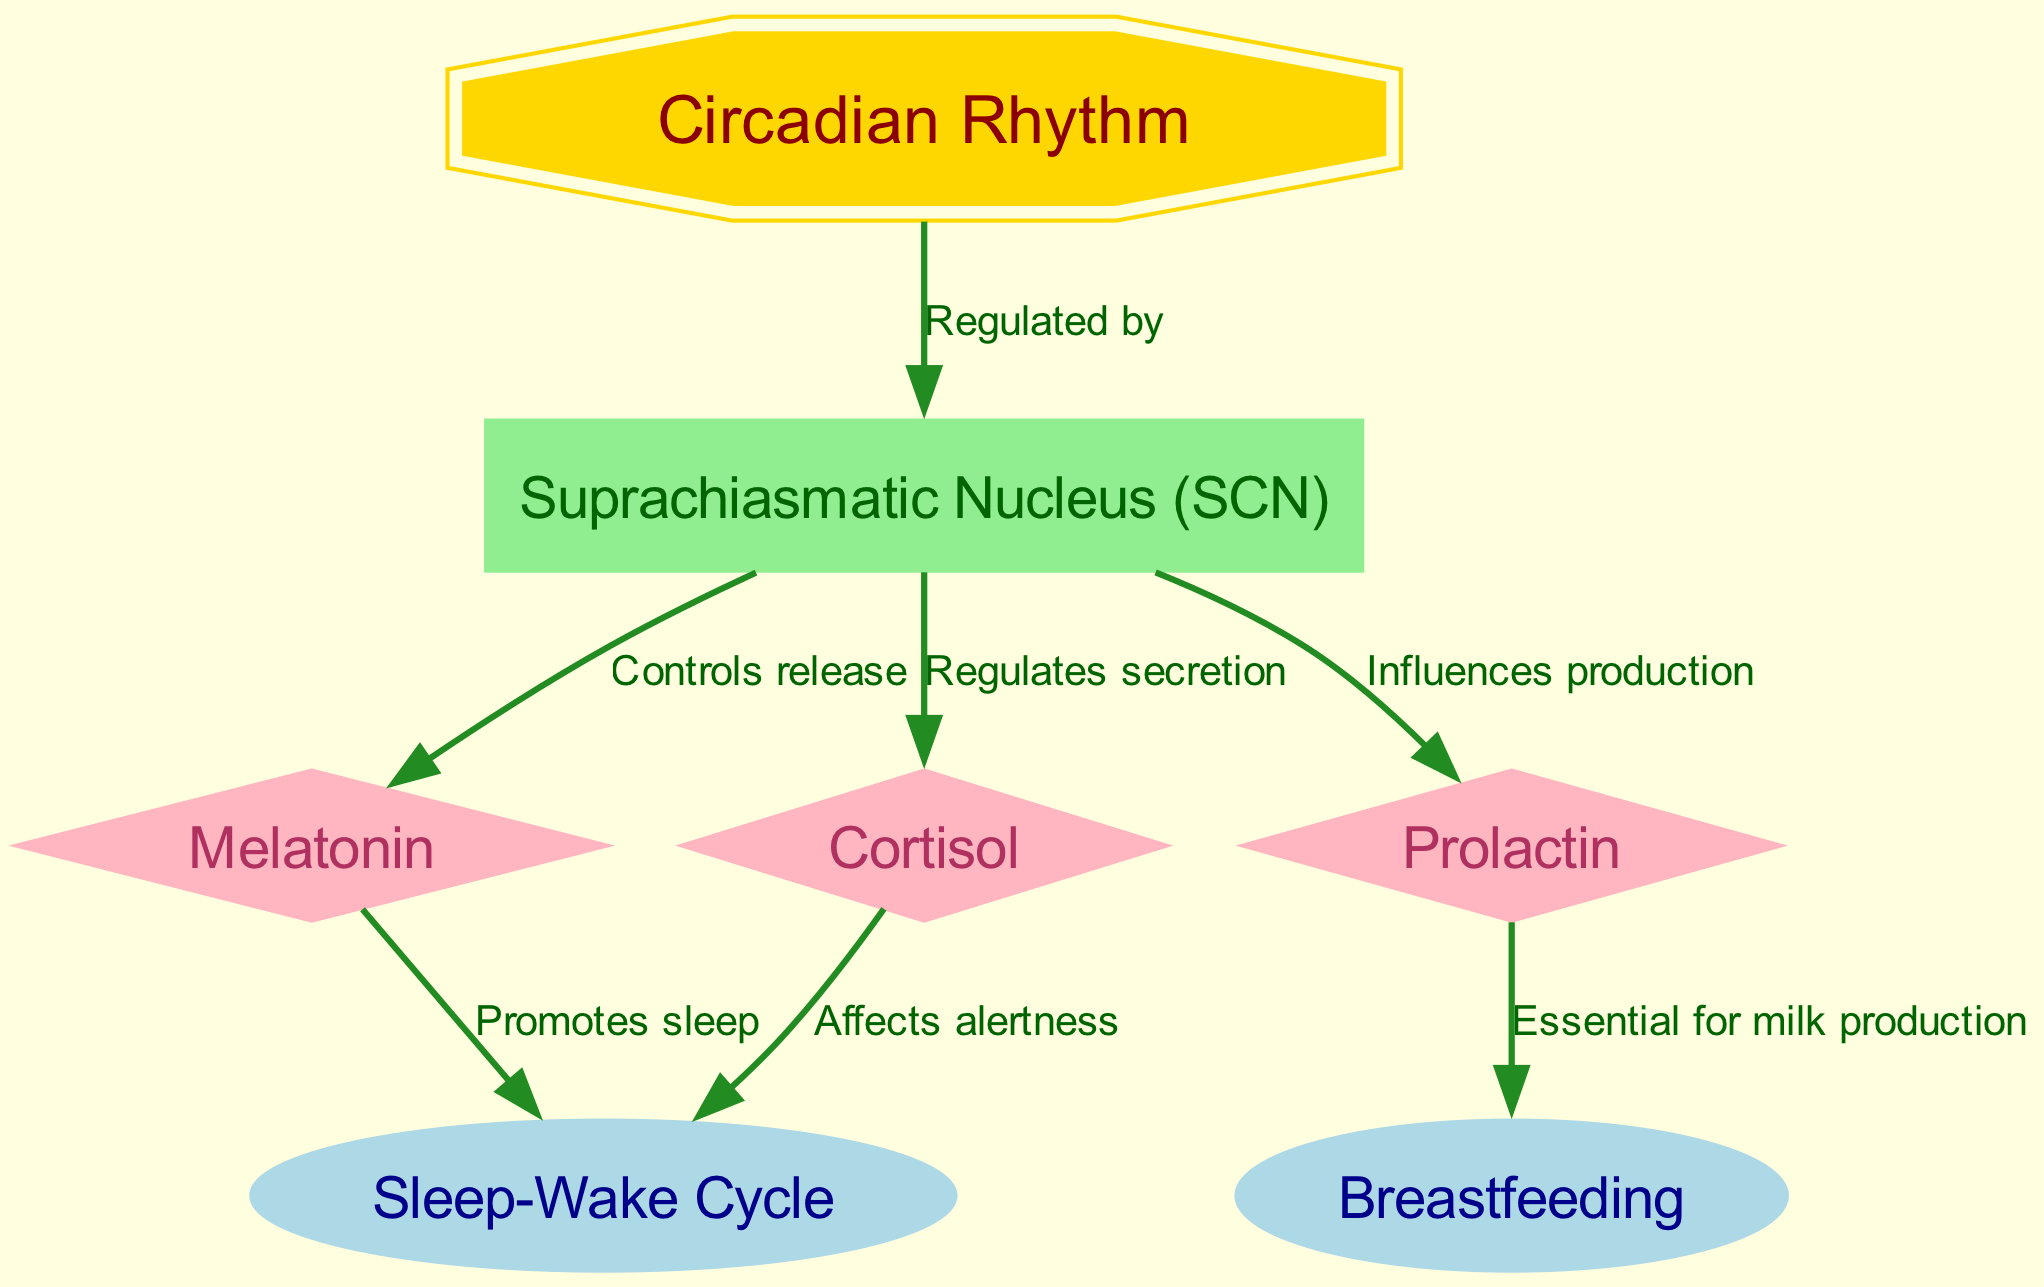What regulates the circadian rhythm? The diagram shows an edge labeled "Regulated by" from "Circadian Rhythm" to "Suprachiasmatic Nucleus (SCN)," indicating that the SCN regulates the circadian rhythm.
Answer: Suprachiasmatic Nucleus (SCN) Which hormone influences prolactin production? The edge from "Suprachiasmatic Nucleus" to "Prolactin" is labeled "Influences production," which means the SCN influences the production of prolactin.
Answer: Suprachiasmatic Nucleus How many hormones are shown in the diagram? By counting the nodes that represent hormones, namely "Melatonin," "Prolactin," and "Cortisol," there are a total of three hormones represented in the diagram.
Answer: 3 What effect does melatonin have on the sleep-wake cycle? The diagram has an edge from "Melatonin" to "Sleep-Wake Cycle" labeled "Promotes sleep," indicating that melatonin promotes sleep within the sleep-wake cycle.
Answer: Promotes sleep Which hormone is essential for milk production? The edge from "Prolactin" to "Breastfeeding" is labeled "Essential for milk production," indicating that prolactin is the hormone essential for that process.
Answer: Prolactin What does cortisol affect according to the diagram? The edge from "Cortisol" to "Sleep-Wake Cycle" is labeled "Affects alertness," which shows that cortisol affects alertness within the context of the sleep-wake cycle.
Answer: Alertness How does the suprachiasmatic nucleus interact with cortisol? The diagram indicates that the suprachiasmatic nucleus regulates the secretion of cortisol, evidenced by the edge labeled "Regulates secretion" from "Suprachiasmatic Nucleus" to "Cortisol."
Answer: Regulates secretion What role does the circadian rhythm play in hormone production? The diagram illustrates that the circadian rhythm, regulated by the suprachiasmatic nucleus, has direct influences on the production of the hormones prolactin and cortisol, as seen in the respective edges from SCN to these hormones.
Answer: Influences hormone production 